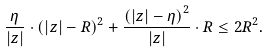Convert formula to latex. <formula><loc_0><loc_0><loc_500><loc_500>\frac { \eta } { | z | } \cdot \left ( | z | - R \right ) ^ { 2 } + \frac { \left ( | z | - \eta \right ) ^ { 2 } } { | z | } \cdot R \leq 2 R ^ { 2 } .</formula> 